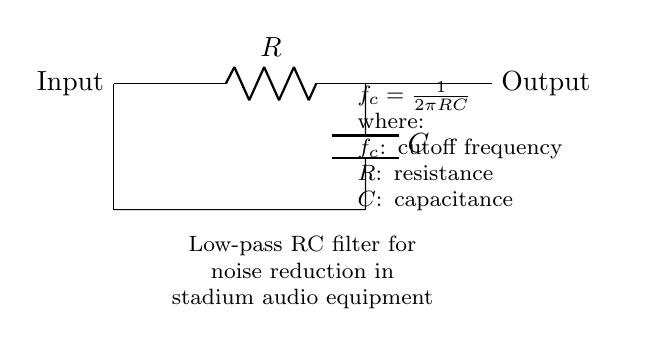What type of circuit is represented? The circuit is a low-pass filter. This can be deduced from the presence of a resistor and a capacitor arranged to filter high-frequency signals and allow low-frequency signals to pass.
Answer: low-pass filter What are the components used in this circuit? The components visible in the circuit are a resistor and a capacitor. These are indicated by their labels on the circuit diagram.
Answer: resistor and capacitor What does the node labeled "Input" signify? The "Input" node indicates where the audio signal enters the circuit for processing. In this context, it is where the original audio with potential noise is applied.
Answer: audio signal input What is the purpose of this circuit in audio equipment? The purpose of this low-pass filter is to reduce noise in stadium audio equipment during announcements by filtering out high-frequency interference.
Answer: noise reduction How is the cutoff frequency calculated? The cutoff frequency is calculated using the formula f_c = 1/(2πRC), where R is the resistance and C is the capacitance. The formula shows the relationship between these three parameters to determine the frequency at which the output signal starts to attenuate.
Answer: 1/(2πRC) What happens to high-frequency signals in this circuit? High-frequency signals are attenuated, meaning they are reduced in magnitude as they pass through the low-pass filter, allowing only low-frequency signals to remain largely unaffected.
Answer: attenuated What is the significance of the node labeled "Output"? The "Output" node represents the point where the filtered audio signal exits the circuit and is sent to the audio equipment for amplification or reproduction.
Answer: filtered audio signal output 